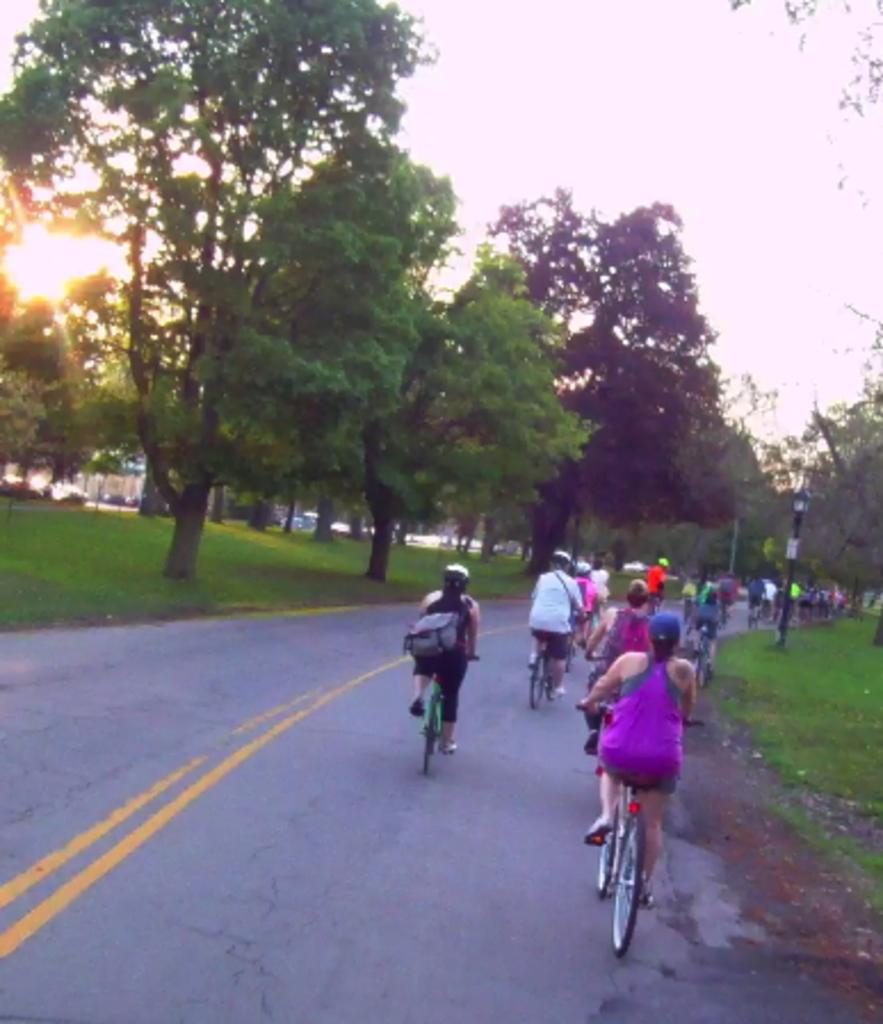What are the people in the image doing? The people in the image are riding bicycles. Can you describe the person with an additional accessory? There is a person wearing a backpack in the image. What is a tall, vertical object in the image? There is a light pole in the image. What type of natural vegetation is present in the image? There are trees in the image. What can be seen in the sky in the image? The sky is visible in the image, and the sun is observable. What type of minister can be seen interacting with the jellyfish in the image? There is no minister or jellyfish present in the image; it features people riding bicycles and other objects and elements. 